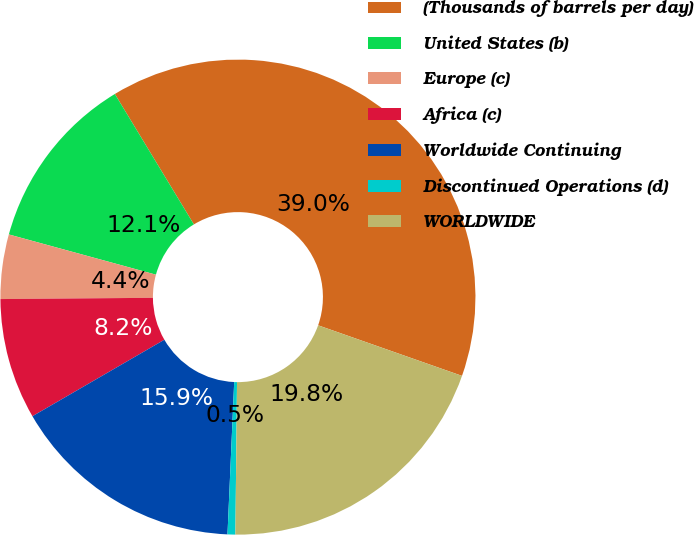<chart> <loc_0><loc_0><loc_500><loc_500><pie_chart><fcel>(Thousands of barrels per day)<fcel>United States (b)<fcel>Europe (c)<fcel>Africa (c)<fcel>Worldwide Continuing<fcel>Discontinued Operations (d)<fcel>WORLDWIDE<nl><fcel>39.05%<fcel>12.08%<fcel>4.38%<fcel>8.23%<fcel>15.94%<fcel>0.53%<fcel>19.79%<nl></chart> 